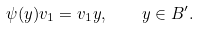Convert formula to latex. <formula><loc_0><loc_0><loc_500><loc_500>\psi ( y ) v _ { 1 } = v _ { 1 } y , \quad y \in B ^ { \prime } .</formula> 